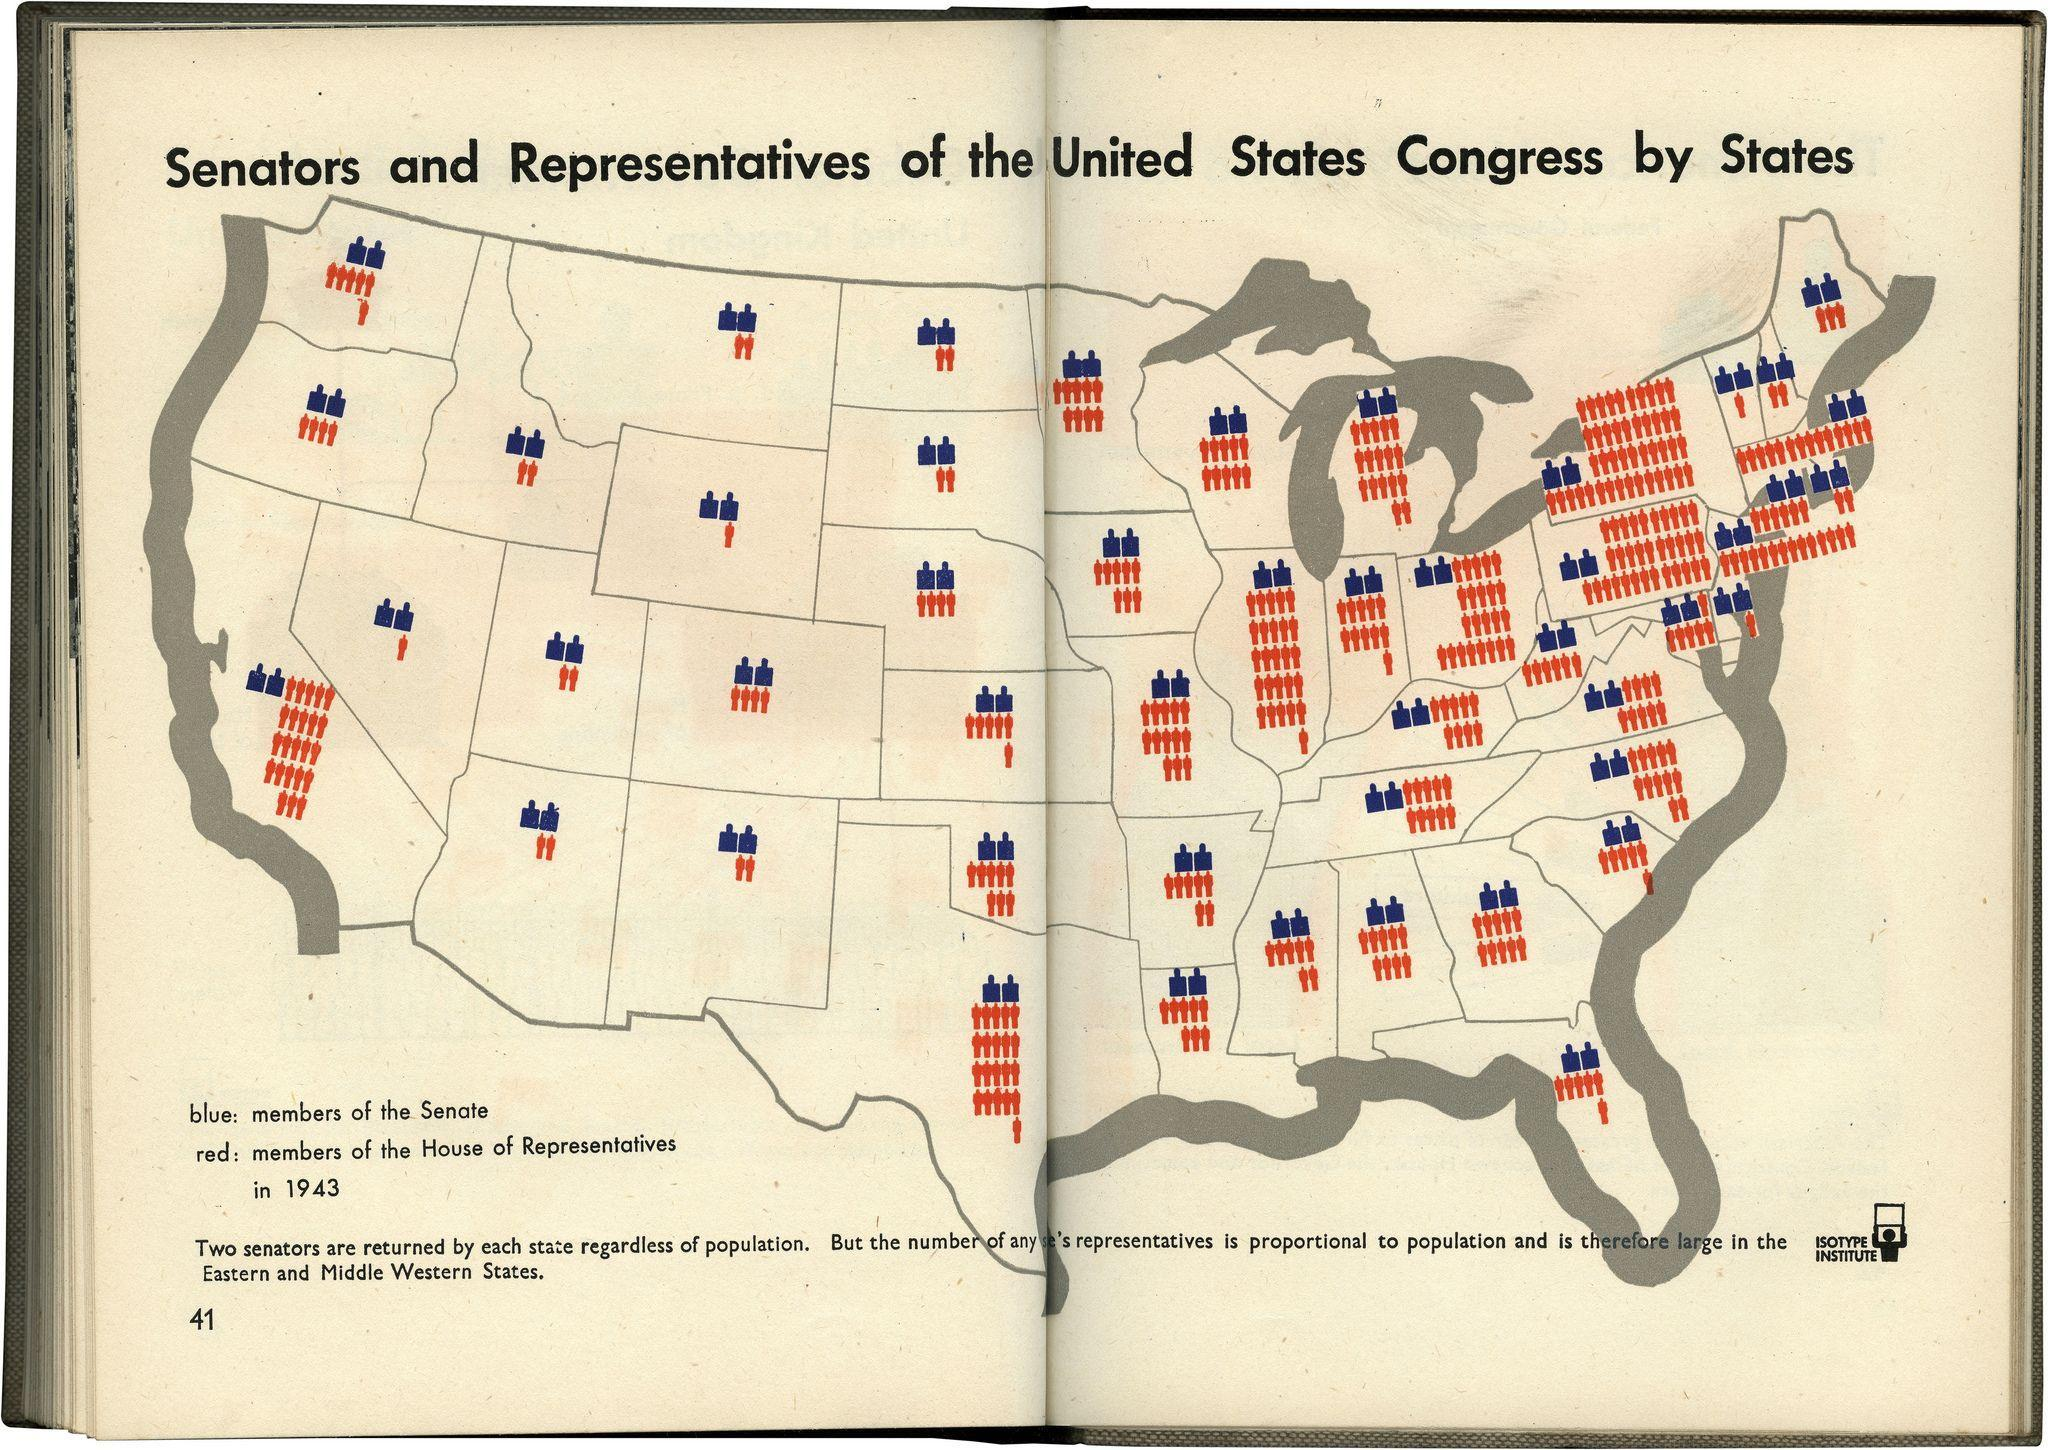Population is lower in which region of the United States - Eastern or Western?
Answer the question with a short phrase. Western 